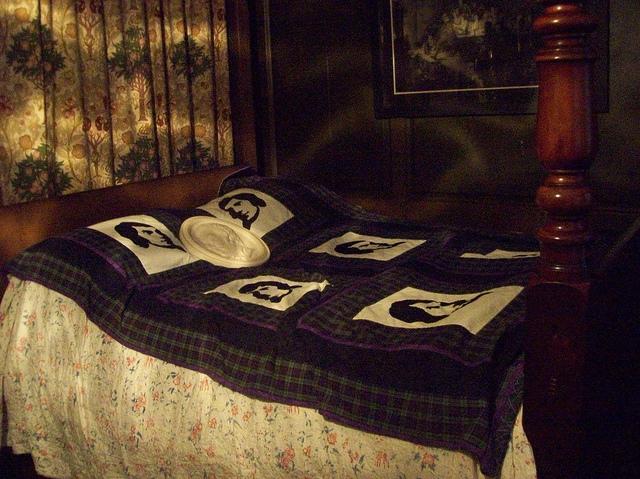What pattern of cloth are these?
Short answer required. Plaid. Is the quilt custom made?
Quick response, please. Yes. Is there a painting on the wall?
Give a very brief answer. Yes. Is this a man or woman's bedroom?
Quick response, please. Woman. 